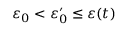<formula> <loc_0><loc_0><loc_500><loc_500>\varepsilon _ { 0 } < \varepsilon _ { 0 } ^ { \prime } \leq \varepsilon ( t )</formula> 